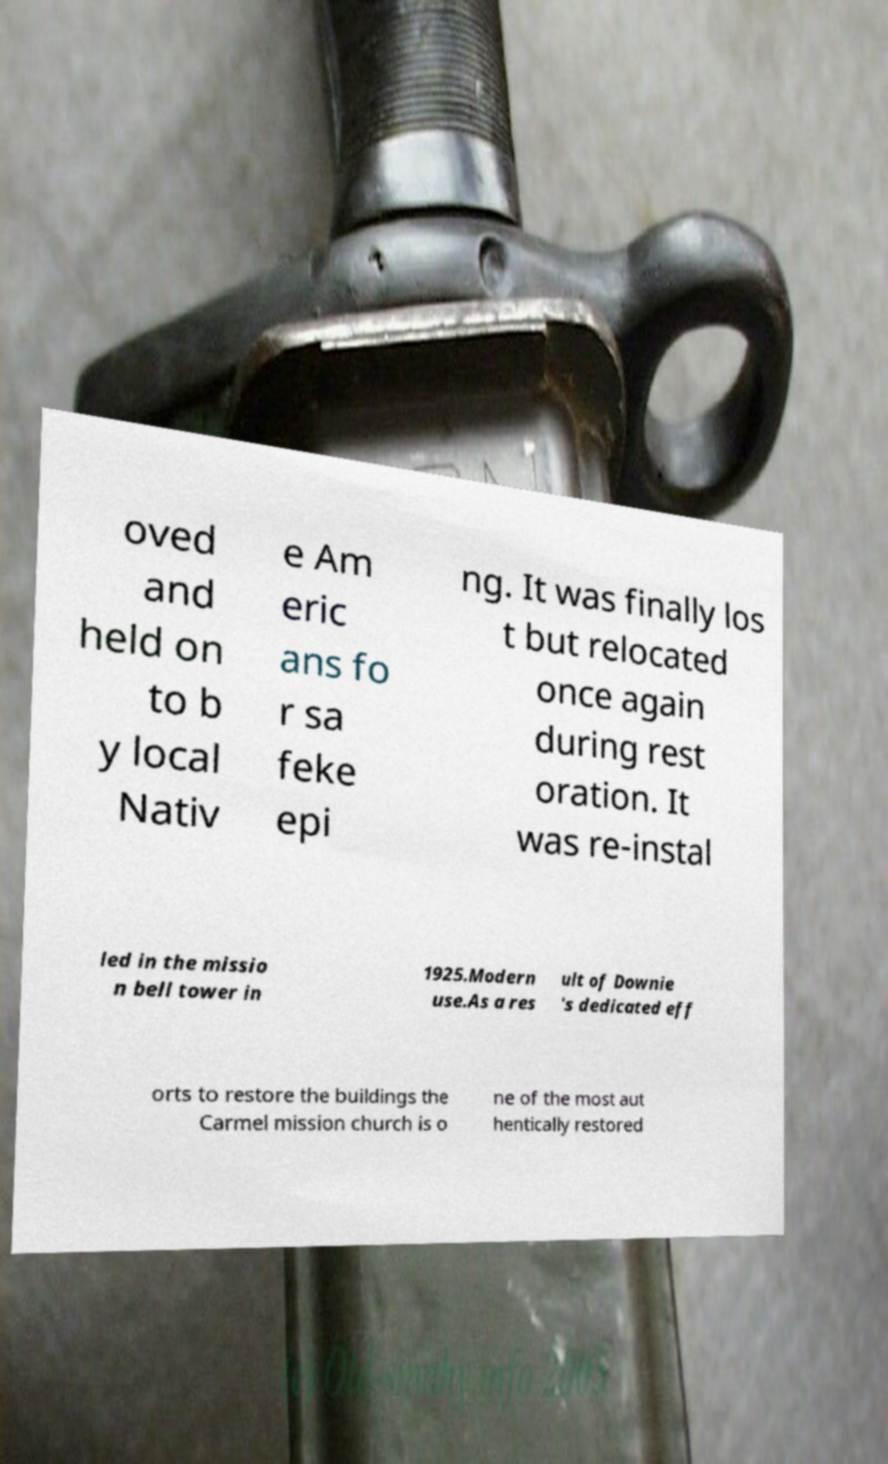Please read and relay the text visible in this image. What does it say? oved and held on to b y local Nativ e Am eric ans fo r sa feke epi ng. It was finally los t but relocated once again during rest oration. It was re-instal led in the missio n bell tower in 1925.Modern use.As a res ult of Downie 's dedicated eff orts to restore the buildings the Carmel mission church is o ne of the most aut hentically restored 